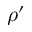Convert formula to latex. <formula><loc_0><loc_0><loc_500><loc_500>\rho ^ { \prime }</formula> 